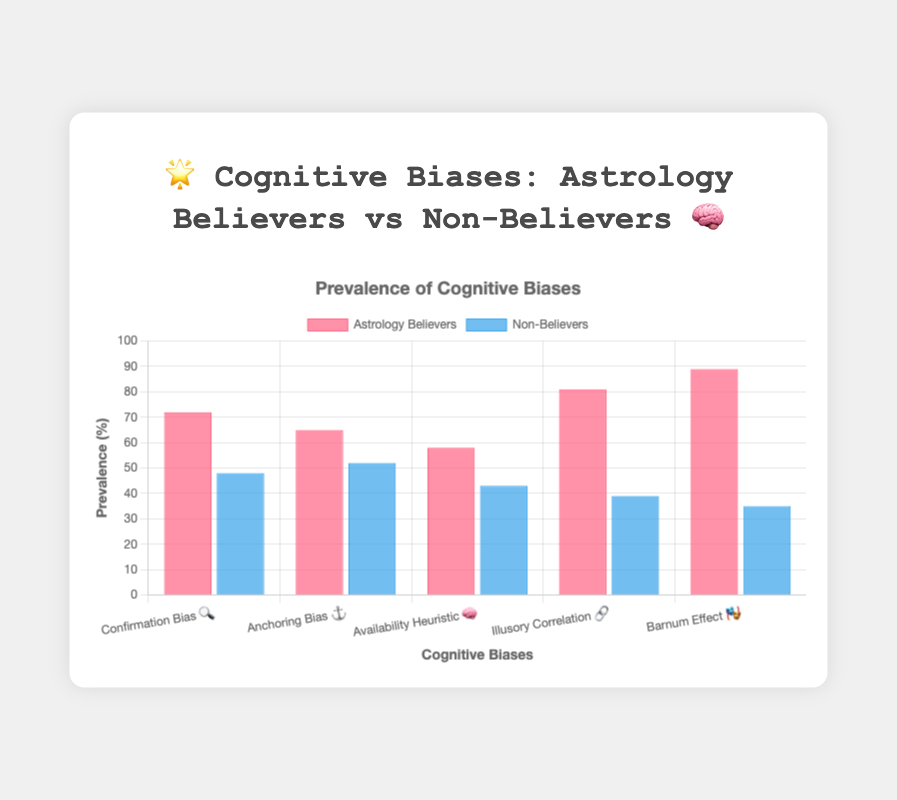What's the title of the figure? The title is prominently displayed at the top of the figure.
Answer: 🌟 Cognitive Biases: Astrology Believers vs Non-Believers 🧠 What is the highest value for astrology believers? The highest bar within the 'Astrology Believers' dataset indicates the highest prevalence, which belongs to the Barnum Effect.
Answer: 89 How many types of cognitive biases are shown in the figure? Counting the labels on the x-axis indicates the number of cognitive biases visualized.
Answer: 5 Which cognitive bias shows the smallest difference between astrology believers and non-believers? By examining the difference between each pair of bars, the smallest difference is seen in the 'Anchoring Bias.'
Answer: 13 What is the average prevalence of cognitive biases for non-believers? Summing up the values for non-believers (48 + 52 + 43 + 39 + 35 = 217) and then dividing by the number of cognitive biases (5) gives the average.
Answer: 43.4 Which cognitive bias has the biggest disparity between astrology believers and non-believers? The 'Barnum Effect' shows the largest gap by comparing all the biases' prevalence differences.
Answer: Barnum Effect 🎭 What color represents astrology believers in the chart? The color of the bars representing astrology believers is consistently shown and mentioned in the figure description.
Answer: Pink (rgba(255, 99, 132, 0.7)) In which cognitive bias do non-believers have nearly half the prevalence compared to astrology believers? The 'Illusory Correlation' shows astrology believers at 81 and non-believers at 39, approximately half.
Answer: Illusory Correlation 🔗 What is the sum of the prevalence percentages for the 'Availability Heuristic' in both groups? Adding the values for astrology believers (58) and non-believers (43) gives the total prevalence percentage.
Answer: 101 Which group has a lower prevalence for every cognitive bias depicted in the chart? By comparing the heights of all the bars, non-believers consistently exhibit a lower prevalence for each cognitive bias.
Answer: Non-believers 